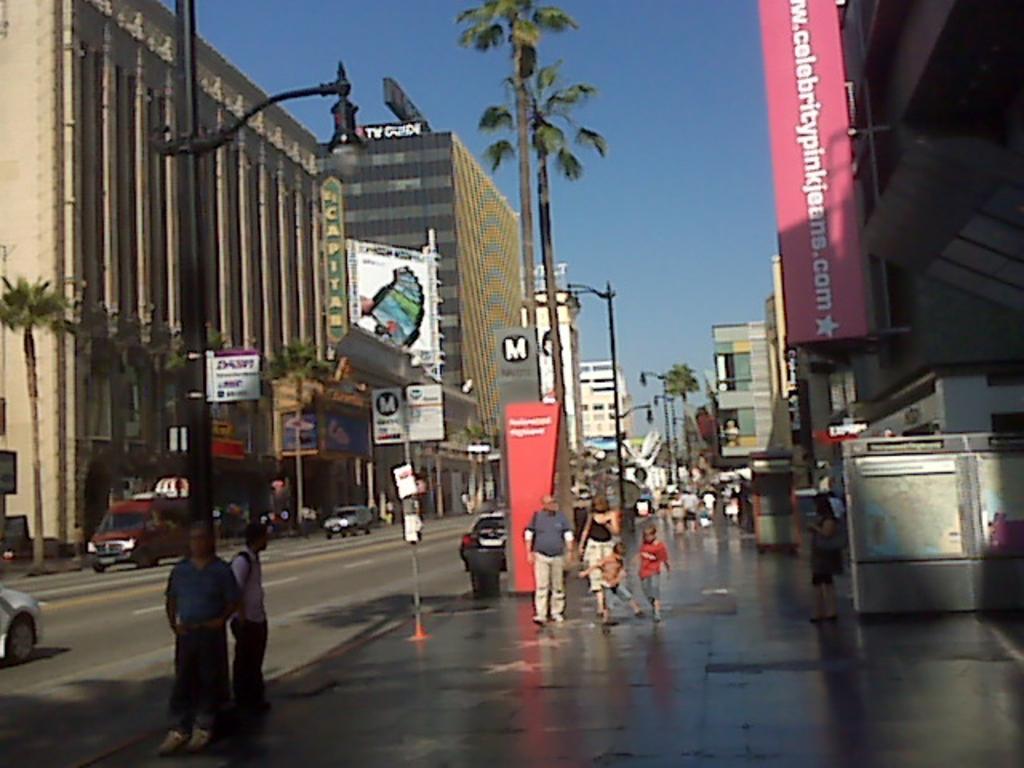Is that tall building just for the tv guide company?
Provide a succinct answer. Yes. 